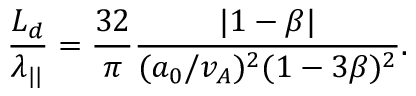Convert formula to latex. <formula><loc_0><loc_0><loc_500><loc_500>\frac { L _ { d } } { \lambda _ { | | } } = \frac { 3 2 } { \pi } \frac { | 1 - \beta | } { ( a _ { 0 } / v _ { A } ) ^ { 2 } ( 1 - 3 \beta ) ^ { 2 } } .</formula> 